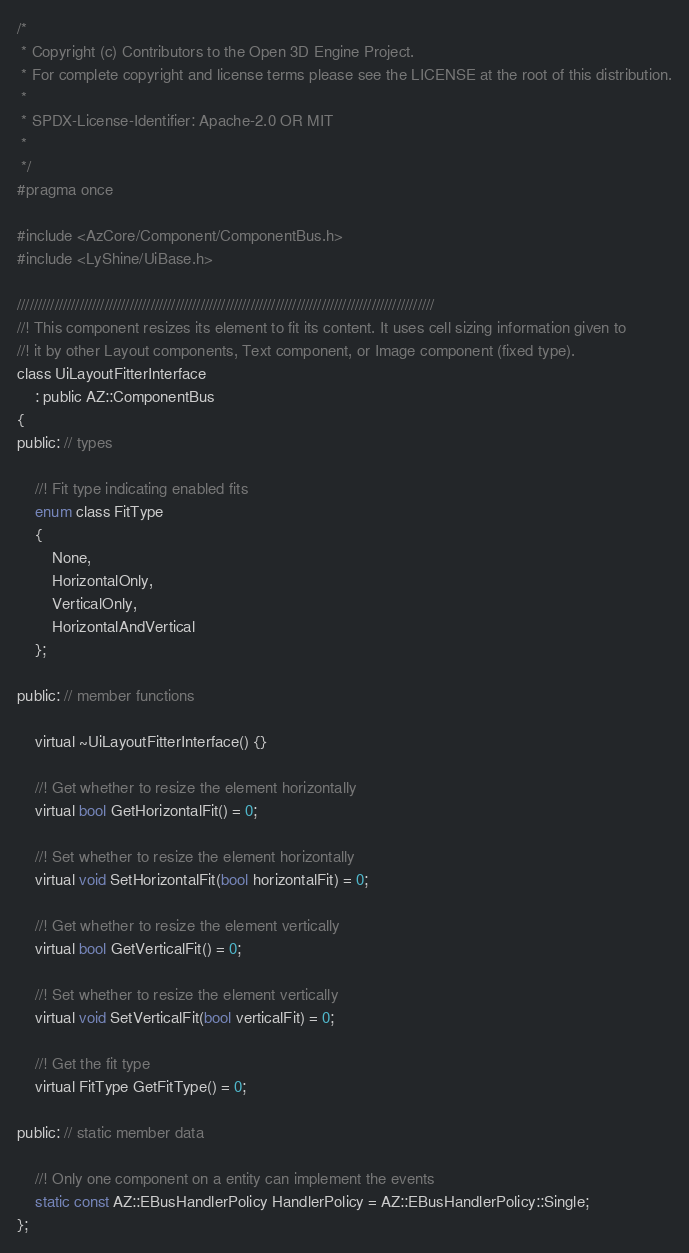Convert code to text. <code><loc_0><loc_0><loc_500><loc_500><_C_>/*
 * Copyright (c) Contributors to the Open 3D Engine Project.
 * For complete copyright and license terms please see the LICENSE at the root of this distribution.
 *
 * SPDX-License-Identifier: Apache-2.0 OR MIT
 *
 */
#pragma once

#include <AzCore/Component/ComponentBus.h>
#include <LyShine/UiBase.h>

////////////////////////////////////////////////////////////////////////////////////////////////////
//! This component resizes its element to fit its content. It uses cell sizing information given to
//! it by other Layout components, Text component, or Image component (fixed type).
class UiLayoutFitterInterface
    : public AZ::ComponentBus
{
public: // types

    //! Fit type indicating enabled fits
    enum class FitType
    {
        None,
        HorizontalOnly,
        VerticalOnly,
        HorizontalAndVertical
    };

public: // member functions

    virtual ~UiLayoutFitterInterface() {}

    //! Get whether to resize the element horizontally
    virtual bool GetHorizontalFit() = 0;

    //! Set whether to resize the element horizontally
    virtual void SetHorizontalFit(bool horizontalFit) = 0;

    //! Get whether to resize the element vertically
    virtual bool GetVerticalFit() = 0;

    //! Set whether to resize the element vertically
    virtual void SetVerticalFit(bool verticalFit) = 0;

    //! Get the fit type
    virtual FitType GetFitType() = 0;

public: // static member data

    //! Only one component on a entity can implement the events
    static const AZ::EBusHandlerPolicy HandlerPolicy = AZ::EBusHandlerPolicy::Single;
};
</code> 